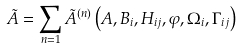Convert formula to latex. <formula><loc_0><loc_0><loc_500><loc_500>\tilde { A } = \sum _ { n = 1 } \tilde { A } ^ { ( n ) } \left ( A , B _ { i } , H _ { i j } , \varphi , \Omega _ { i } , \Gamma _ { i j } \right )</formula> 